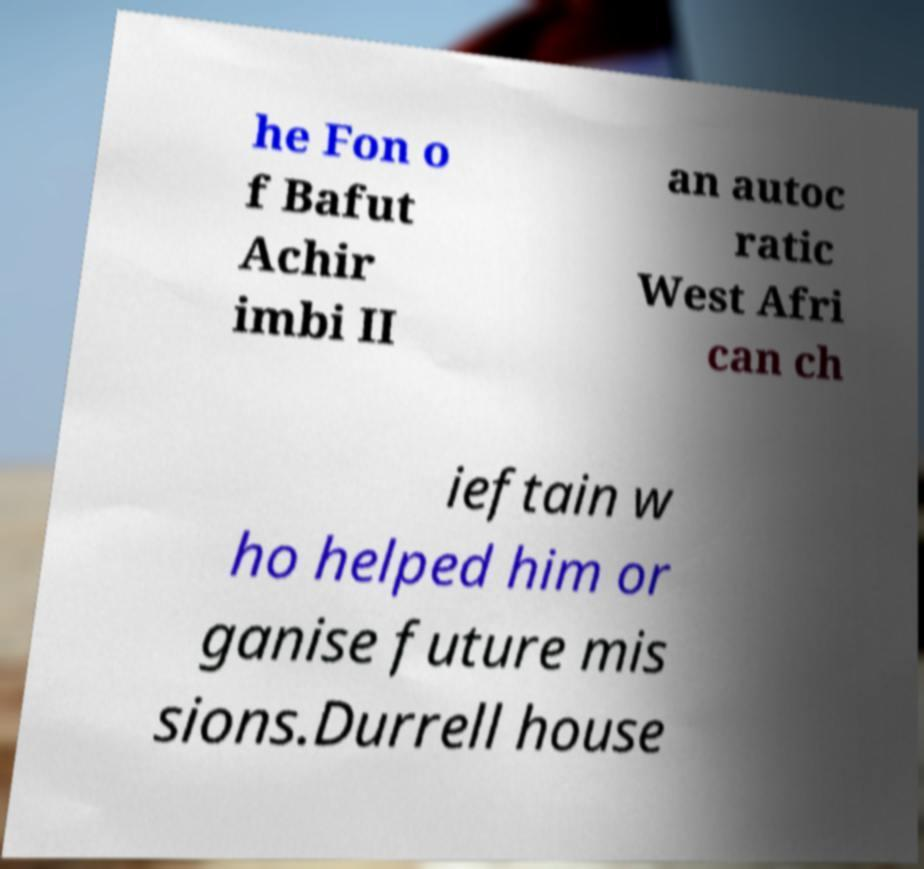Please identify and transcribe the text found in this image. he Fon o f Bafut Achir imbi II an autoc ratic West Afri can ch ieftain w ho helped him or ganise future mis sions.Durrell house 